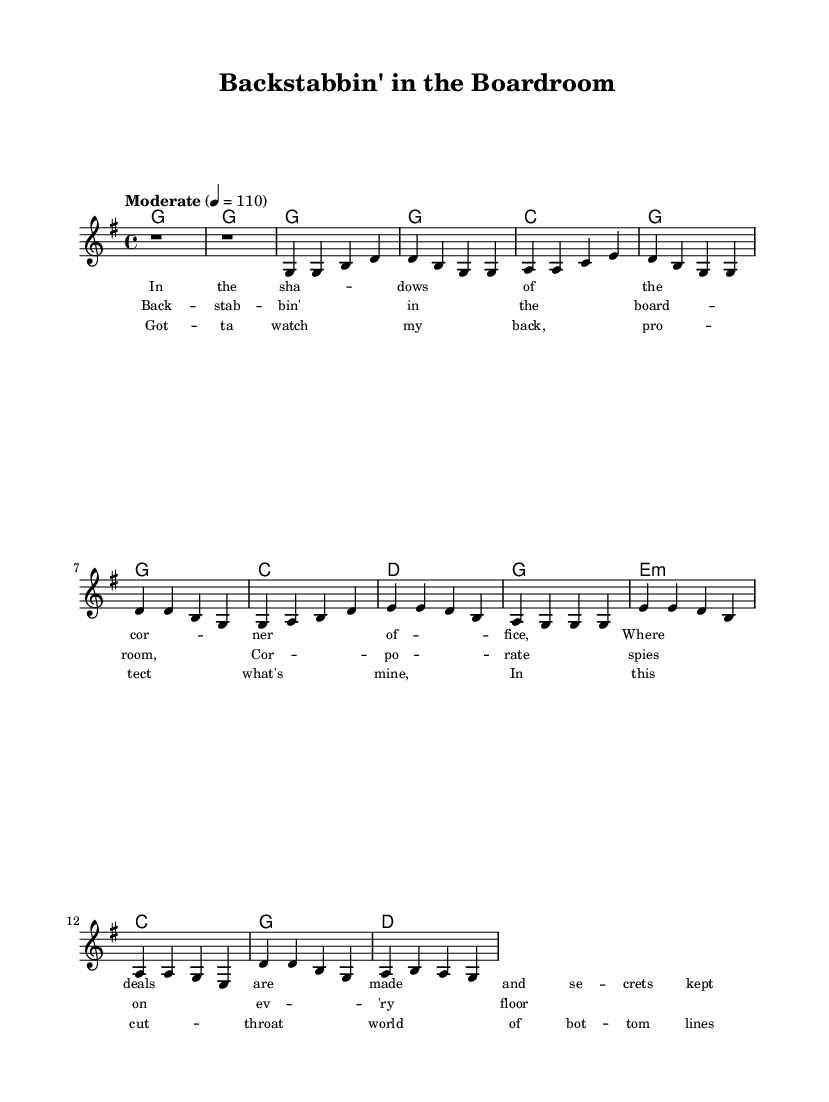What is the key signature of this music? The key signature is G major, which has one sharp (F#). This can be identified by looking at the key signature indicated at the beginning of the sheet music.
Answer: G major What is the time signature of the music? The time signature is 4/4, as denoted by the fraction present in the music. This indicates that there are four beats per measure and the quarter note gets one beat.
Answer: 4/4 What is the tempo marking for this piece? The tempo marking is "Moderate" with a metronome marking of 110. This indicates the speed to play the piece without the need for further indications.
Answer: Moderate How many measures are in the chorus section? The chorus section consists of four measures. By counting the measures indicated in the sheet music where the chorus lyrics are provided, we find there are four.
Answer: 4 Which chord is played in the bridge? The bridge features an E minor chord as indicated by the chord-mode section of the music. This is the first harmony listed for the bridge.
Answer: E minor What lyrical theme is highlighted in the chorus? The chorus emphasizes a theme of corporate espionage and betrayal, as indicated by the lyrics referencing "backstabbin' in the boardroom" and "corporate spies." This gives insight into the overarching narrative of the song.
Answer: Corporate espionage What is the phrase structure of the verse section? The verse consists of four lines of lyrics, which align with the musical measures. This mirroring structure indicates a straightforward arrangement typical in Country music.
Answer: Four lines 